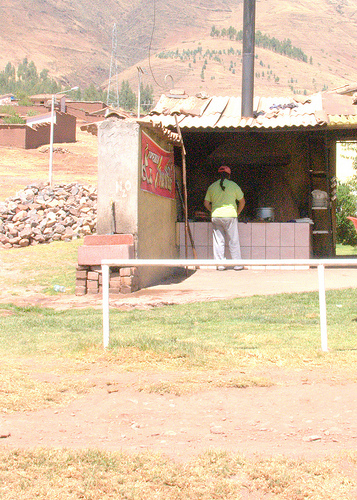<image>
Is the stack above the man? Yes. The stack is positioned above the man in the vertical space, higher up in the scene. 